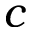Convert formula to latex. <formula><loc_0><loc_0><loc_500><loc_500>c</formula> 